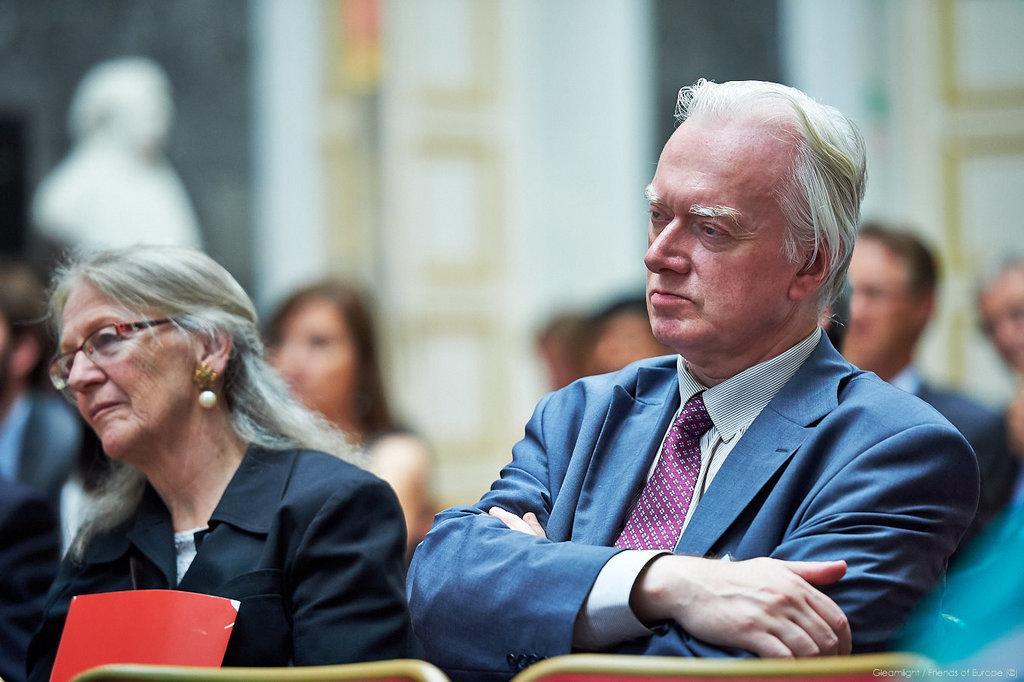Describe this image in one or two sentences. In this image people are sitting on chairs, in the background it is blurred. 